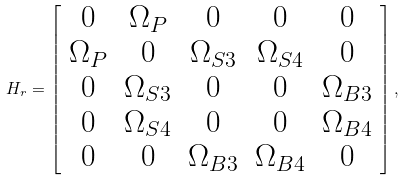<formula> <loc_0><loc_0><loc_500><loc_500>H _ { r } = \left [ \begin{array} { c c c c c } 0 & \Omega _ { P } & 0 & 0 & 0 \\ \Omega _ { P } & 0 & \Omega _ { S 3 } & \Omega _ { S 4 } & 0 \\ 0 & \Omega _ { S 3 } & 0 & 0 & \Omega _ { B 3 } \\ 0 & \Omega _ { S 4 } & 0 & 0 & \Omega _ { B 4 } \\ 0 & 0 & \Omega _ { B 3 } & \Omega _ { B 4 } & 0 \\ \end{array} \right ] ,</formula> 